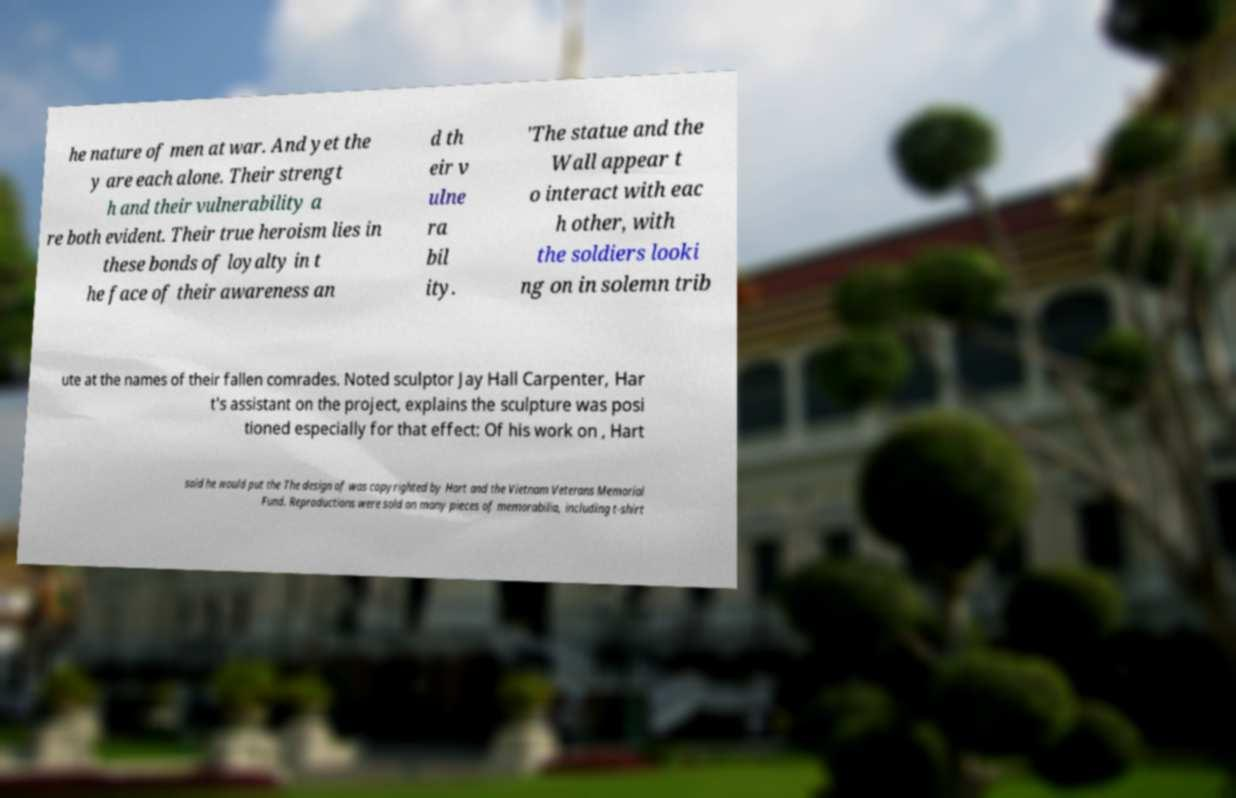Can you accurately transcribe the text from the provided image for me? he nature of men at war. And yet the y are each alone. Their strengt h and their vulnerability a re both evident. Their true heroism lies in these bonds of loyalty in t he face of their awareness an d th eir v ulne ra bil ity. 'The statue and the Wall appear t o interact with eac h other, with the soldiers looki ng on in solemn trib ute at the names of their fallen comrades. Noted sculptor Jay Hall Carpenter, Har t's assistant on the project, explains the sculpture was posi tioned especially for that effect: Of his work on , Hart said he would put the The design of was copyrighted by Hart and the Vietnam Veterans Memorial Fund. Reproductions were sold on many pieces of memorabilia, including t-shirt 